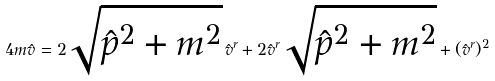<formula> <loc_0><loc_0><loc_500><loc_500>4 m { \hat { v } } = 2 \sqrt { { \hat { p } } ^ { 2 } + m ^ { 2 } } \, { \hat { v } } ^ { r } + 2 { \hat { v } } ^ { r } \sqrt { { \hat { p } } ^ { 2 } + m ^ { 2 } } + ( { \hat { v } } ^ { r } ) ^ { 2 }</formula> 